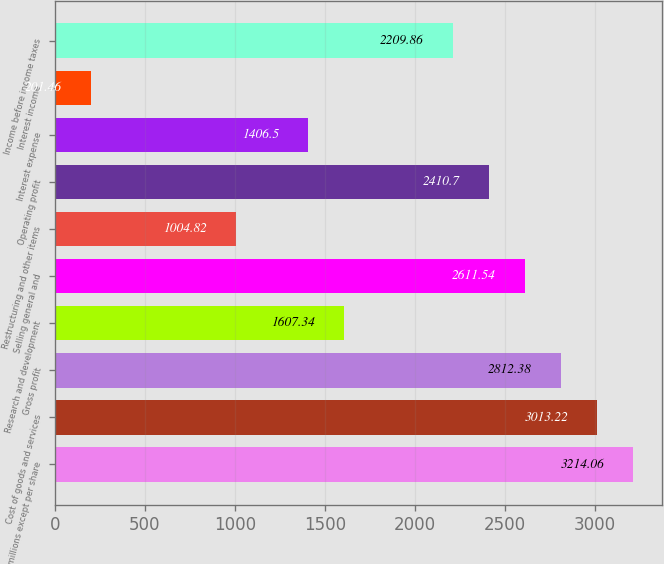Convert chart. <chart><loc_0><loc_0><loc_500><loc_500><bar_chart><fcel>(in millions except per share<fcel>Cost of goods and services<fcel>Gross profit<fcel>Research and development<fcel>Selling general and<fcel>Restructuring and other items<fcel>Operating profit<fcel>Interest expense<fcel>Interest income<fcel>Income before income taxes<nl><fcel>3214.06<fcel>3013.22<fcel>2812.38<fcel>1607.34<fcel>2611.54<fcel>1004.82<fcel>2410.7<fcel>1406.5<fcel>201.46<fcel>2209.86<nl></chart> 